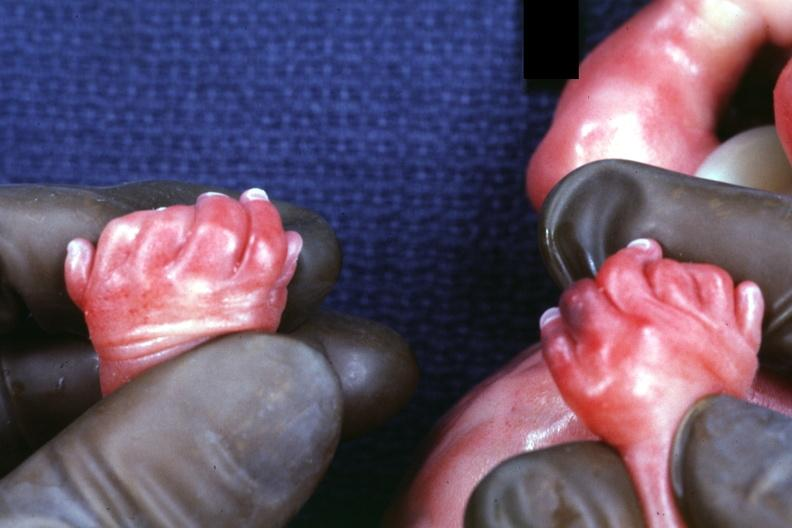how many digits and syndactyly is present?
Answer the question using a single word or phrase. Six 